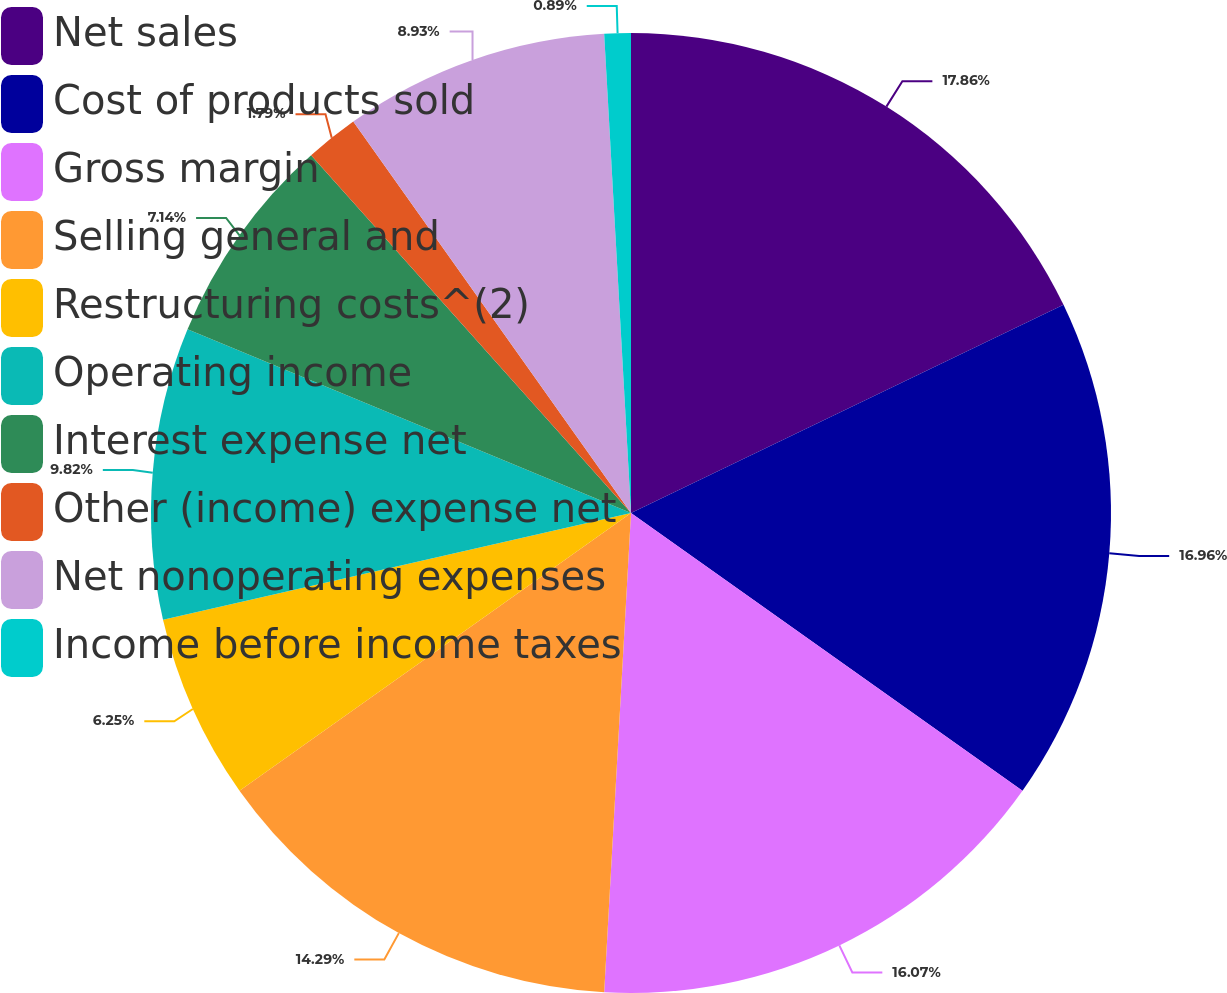Convert chart. <chart><loc_0><loc_0><loc_500><loc_500><pie_chart><fcel>Net sales<fcel>Cost of products sold<fcel>Gross margin<fcel>Selling general and<fcel>Restructuring costs^(2)<fcel>Operating income<fcel>Interest expense net<fcel>Other (income) expense net<fcel>Net nonoperating expenses<fcel>Income before income taxes<nl><fcel>17.86%<fcel>16.96%<fcel>16.07%<fcel>14.29%<fcel>6.25%<fcel>9.82%<fcel>7.14%<fcel>1.79%<fcel>8.93%<fcel>0.89%<nl></chart> 